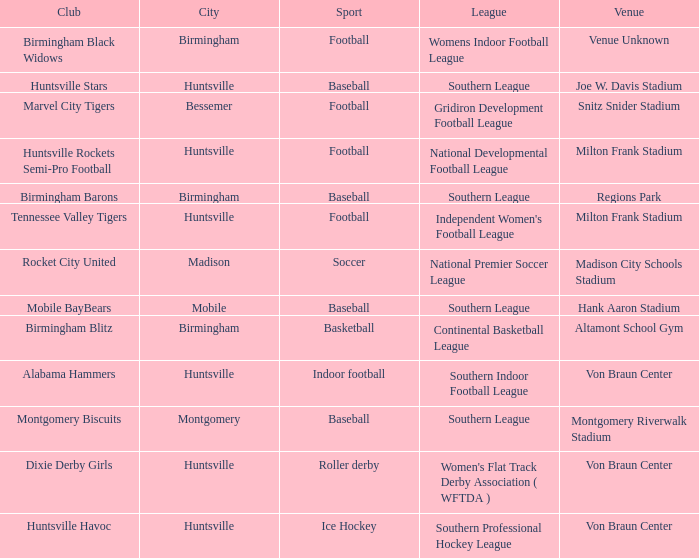Which sport had the club of the Montgomery Biscuits? Baseball. 